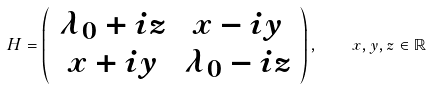Convert formula to latex. <formula><loc_0><loc_0><loc_500><loc_500>H = \left ( \begin{array} { c c } \lambda _ { 0 } + i z & x - i y \\ x + i y & \lambda _ { 0 } - i z \\ \end{array} \right ) , \quad x , y , z \in \mathbb { R }</formula> 